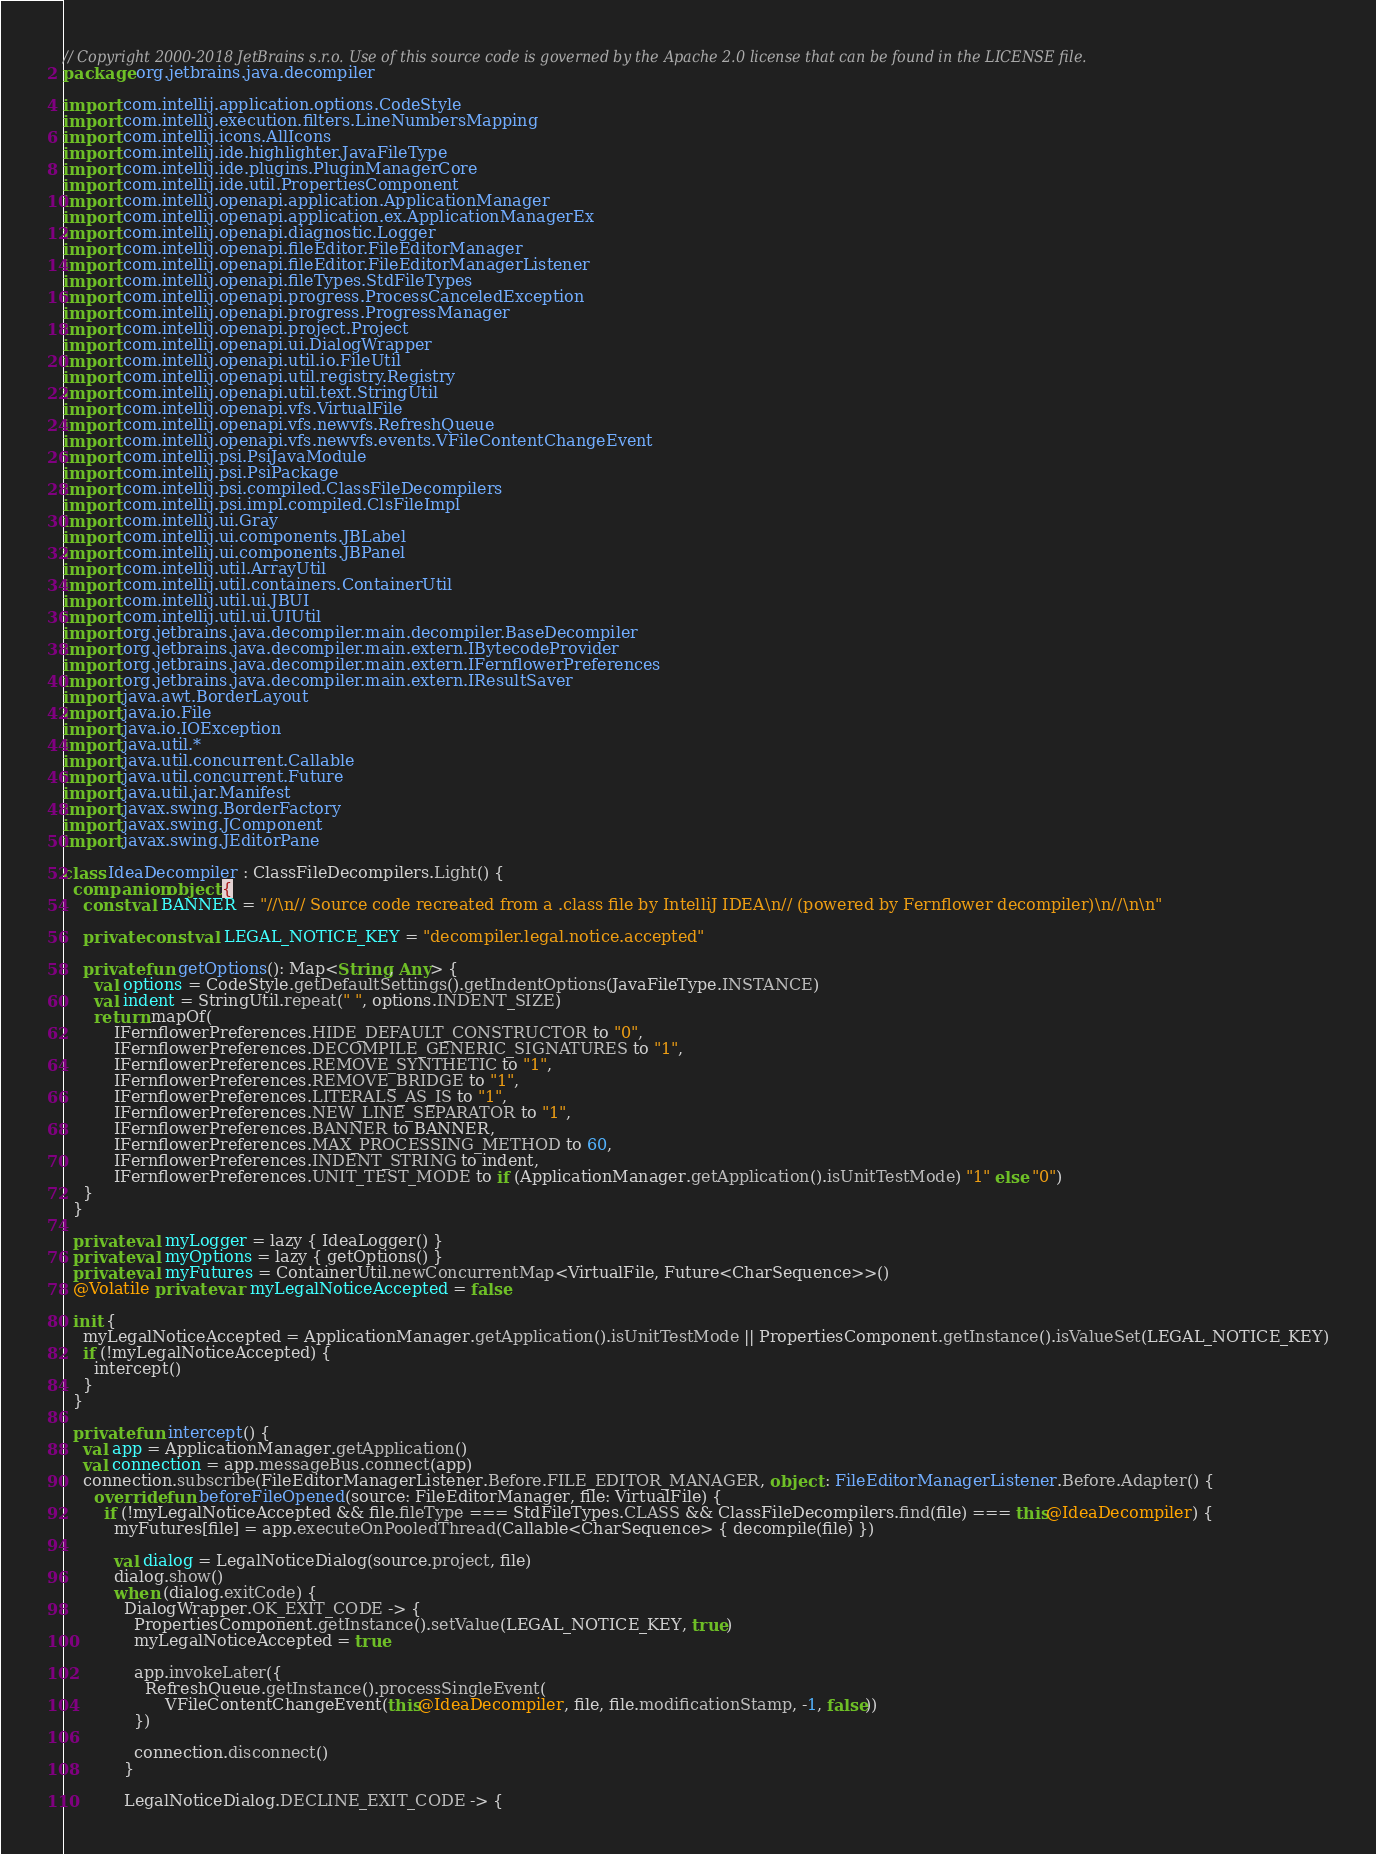Convert code to text. <code><loc_0><loc_0><loc_500><loc_500><_Kotlin_>// Copyright 2000-2018 JetBrains s.r.o. Use of this source code is governed by the Apache 2.0 license that can be found in the LICENSE file.
package org.jetbrains.java.decompiler

import com.intellij.application.options.CodeStyle
import com.intellij.execution.filters.LineNumbersMapping
import com.intellij.icons.AllIcons
import com.intellij.ide.highlighter.JavaFileType
import com.intellij.ide.plugins.PluginManagerCore
import com.intellij.ide.util.PropertiesComponent
import com.intellij.openapi.application.ApplicationManager
import com.intellij.openapi.application.ex.ApplicationManagerEx
import com.intellij.openapi.diagnostic.Logger
import com.intellij.openapi.fileEditor.FileEditorManager
import com.intellij.openapi.fileEditor.FileEditorManagerListener
import com.intellij.openapi.fileTypes.StdFileTypes
import com.intellij.openapi.progress.ProcessCanceledException
import com.intellij.openapi.progress.ProgressManager
import com.intellij.openapi.project.Project
import com.intellij.openapi.ui.DialogWrapper
import com.intellij.openapi.util.io.FileUtil
import com.intellij.openapi.util.registry.Registry
import com.intellij.openapi.util.text.StringUtil
import com.intellij.openapi.vfs.VirtualFile
import com.intellij.openapi.vfs.newvfs.RefreshQueue
import com.intellij.openapi.vfs.newvfs.events.VFileContentChangeEvent
import com.intellij.psi.PsiJavaModule
import com.intellij.psi.PsiPackage
import com.intellij.psi.compiled.ClassFileDecompilers
import com.intellij.psi.impl.compiled.ClsFileImpl
import com.intellij.ui.Gray
import com.intellij.ui.components.JBLabel
import com.intellij.ui.components.JBPanel
import com.intellij.util.ArrayUtil
import com.intellij.util.containers.ContainerUtil
import com.intellij.util.ui.JBUI
import com.intellij.util.ui.UIUtil
import org.jetbrains.java.decompiler.main.decompiler.BaseDecompiler
import org.jetbrains.java.decompiler.main.extern.IBytecodeProvider
import org.jetbrains.java.decompiler.main.extern.IFernflowerPreferences
import org.jetbrains.java.decompiler.main.extern.IResultSaver
import java.awt.BorderLayout
import java.io.File
import java.io.IOException
import java.util.*
import java.util.concurrent.Callable
import java.util.concurrent.Future
import java.util.jar.Manifest
import javax.swing.BorderFactory
import javax.swing.JComponent
import javax.swing.JEditorPane

class IdeaDecompiler : ClassFileDecompilers.Light() {
  companion object {
    const val BANNER = "//\n// Source code recreated from a .class file by IntelliJ IDEA\n// (powered by Fernflower decompiler)\n//\n\n"

    private const val LEGAL_NOTICE_KEY = "decompiler.legal.notice.accepted"

    private fun getOptions(): Map<String, Any> {
      val options = CodeStyle.getDefaultSettings().getIndentOptions(JavaFileType.INSTANCE)
      val indent = StringUtil.repeat(" ", options.INDENT_SIZE)
      return mapOf(
          IFernflowerPreferences.HIDE_DEFAULT_CONSTRUCTOR to "0",
          IFernflowerPreferences.DECOMPILE_GENERIC_SIGNATURES to "1",
          IFernflowerPreferences.REMOVE_SYNTHETIC to "1",
          IFernflowerPreferences.REMOVE_BRIDGE to "1",
          IFernflowerPreferences.LITERALS_AS_IS to "1",
          IFernflowerPreferences.NEW_LINE_SEPARATOR to "1",
          IFernflowerPreferences.BANNER to BANNER,
          IFernflowerPreferences.MAX_PROCESSING_METHOD to 60,
          IFernflowerPreferences.INDENT_STRING to indent,
          IFernflowerPreferences.UNIT_TEST_MODE to if (ApplicationManager.getApplication().isUnitTestMode) "1" else "0")
    }
  }

  private val myLogger = lazy { IdeaLogger() }
  private val myOptions = lazy { getOptions() }
  private val myFutures = ContainerUtil.newConcurrentMap<VirtualFile, Future<CharSequence>>()
  @Volatile private var myLegalNoticeAccepted = false

  init {
    myLegalNoticeAccepted = ApplicationManager.getApplication().isUnitTestMode || PropertiesComponent.getInstance().isValueSet(LEGAL_NOTICE_KEY)
    if (!myLegalNoticeAccepted) {
      intercept()
    }
  }

  private fun intercept() {
    val app = ApplicationManager.getApplication()
    val connection = app.messageBus.connect(app)
    connection.subscribe(FileEditorManagerListener.Before.FILE_EDITOR_MANAGER, object : FileEditorManagerListener.Before.Adapter() {
      override fun beforeFileOpened(source: FileEditorManager, file: VirtualFile) {
        if (!myLegalNoticeAccepted && file.fileType === StdFileTypes.CLASS && ClassFileDecompilers.find(file) === this@IdeaDecompiler) {
          myFutures[file] = app.executeOnPooledThread(Callable<CharSequence> { decompile(file) })

          val dialog = LegalNoticeDialog(source.project, file)
          dialog.show()
          when (dialog.exitCode) {
            DialogWrapper.OK_EXIT_CODE -> {
              PropertiesComponent.getInstance().setValue(LEGAL_NOTICE_KEY, true)
              myLegalNoticeAccepted = true

              app.invokeLater({
                RefreshQueue.getInstance().processSingleEvent(
                    VFileContentChangeEvent(this@IdeaDecompiler, file, file.modificationStamp, -1, false))
              })

              connection.disconnect()
            }

            LegalNoticeDialog.DECLINE_EXIT_CODE -> {</code> 